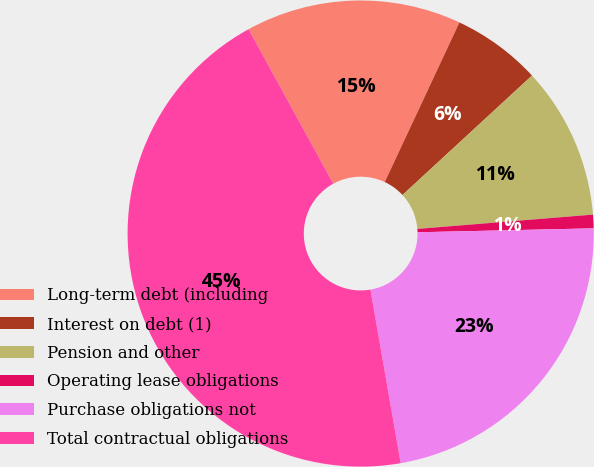Convert chart. <chart><loc_0><loc_0><loc_500><loc_500><pie_chart><fcel>Long-term debt (including<fcel>Interest on debt (1)<fcel>Pension and other<fcel>Operating lease obligations<fcel>Purchase obligations not<fcel>Total contractual obligations<nl><fcel>14.95%<fcel>6.18%<fcel>10.56%<fcel>0.94%<fcel>22.61%<fcel>44.76%<nl></chart> 